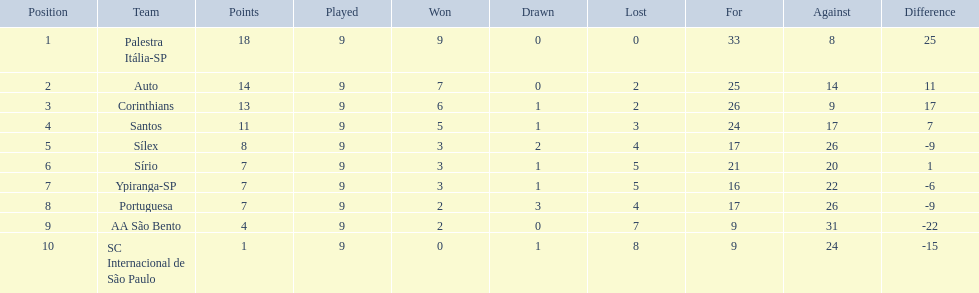In 1926 brazilian football,what was the total number of points scored? 90. 